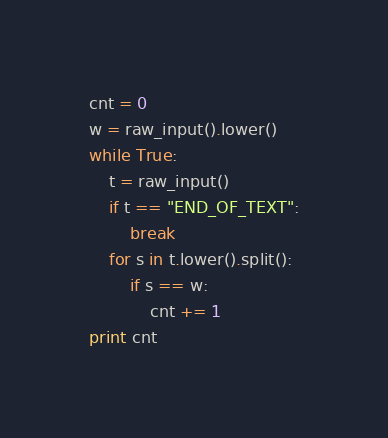Convert code to text. <code><loc_0><loc_0><loc_500><loc_500><_Python_>cnt = 0
w = raw_input().lower()
while True:
    t = raw_input()
    if t == "END_OF_TEXT":
        break
    for s in t.lower().split():
        if s == w:
            cnt += 1
print cnt</code> 